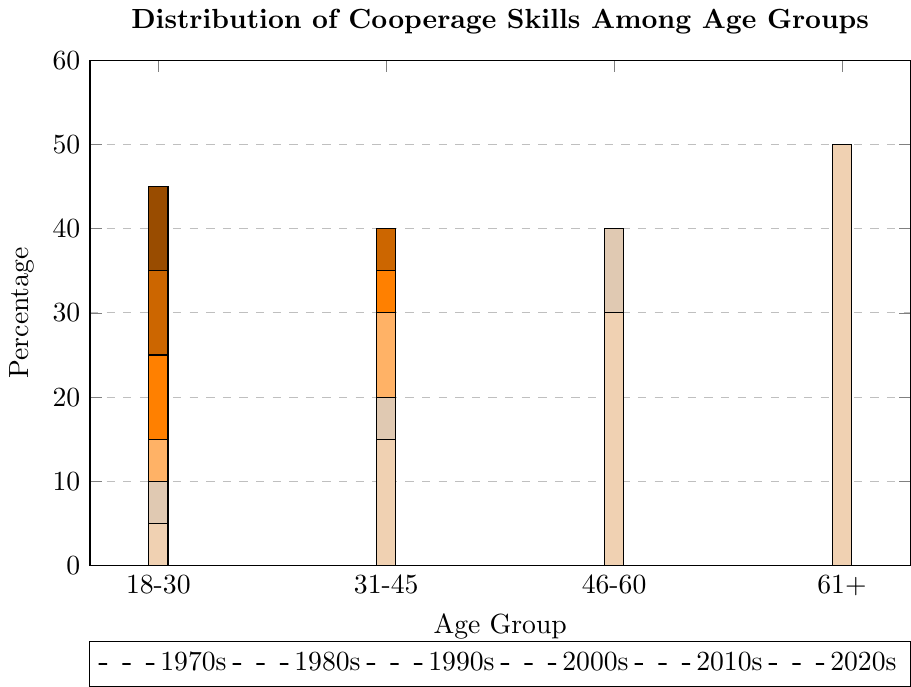What's the trend of the 18-30 age group's percentage from the 1970s to 2020s? To determine the trend, examine the height of the bars for the 18-30 age group across the decades. Notice that the percentage steadily decreases from 45% in the 1970s to 5% in the 2020s.
Answer: Steadily decreasing Which age group showed the most significant increase in cooperage skills percentage over the last 50 years? Compare the difference in heights of the bars from the 1970s to the 2020s for all age groups. The 61+ age group increased from 5% to 50%, showing the most significant increase.
Answer: 61+ In which decade did the 31-45 age group have the highest percentage of cooperage skills? Find the highest bar for the 31-45 age group. This occurs in the 1980s with a percentage of 40%.
Answer: 1980s What is the combined percentage of cooperage skills for the 46-60 age group in the 2010s and 2020s? Add the percentages of the 46-60 age group for the 2010s (40%) and 2020s (30%). 40 + 30 = 70%.
Answer: 70% How does the percentage of the 46-60 age group in the 2000s compare to that of the 18-30 age group in the 1970s? Compare the heights of the bars: the 46-60 age group in the 2000s is 35%, while the 18-30 age group in the 1970s is 45%.
Answer: 10% lower Which decade saw the most significant decrease in the percentage for the 31-45 age group? Identify the decade with the greatest drop in the percentage for the 31-45 age group. The largest decrease is from the 1980s (40%) to the 2010s (20%), a 20% drop.
Answer: Between 1980s and 2010s What is the difference between the percentage of the 61+ age group and the 18-30 age group in the 2020s? Subtract the percentage of the 18-30 age group (5%) from the 61+ age group (50%) in the 2020s. 50 - 5 = 45%.
Answer: 45% Which age group had the lowest percentage in the 1990s, and what was that percentage? Look for the smallest bar in the 1990s. The 61+ age group had the lowest percentage at 10%.
Answer: 61+, 10% What's the overall trend for the 46-60 age group from the 1970s to 2020s? Observe the bar heights for the 46-60 age group. The trend shows an increase from the 1970s (15%) to 2010s (40%), followed by a slight decrease to 30% in the 2020s.
Answer: Increasing then slight decrease What is the total percentage across all age groups for the 1970s? Add the percentages for each age group in the 1970s: 18-30 (45%) + 31-45 (35%) + 46-60 (15%) + 61+ (5%) = 100%.
Answer: 100% 